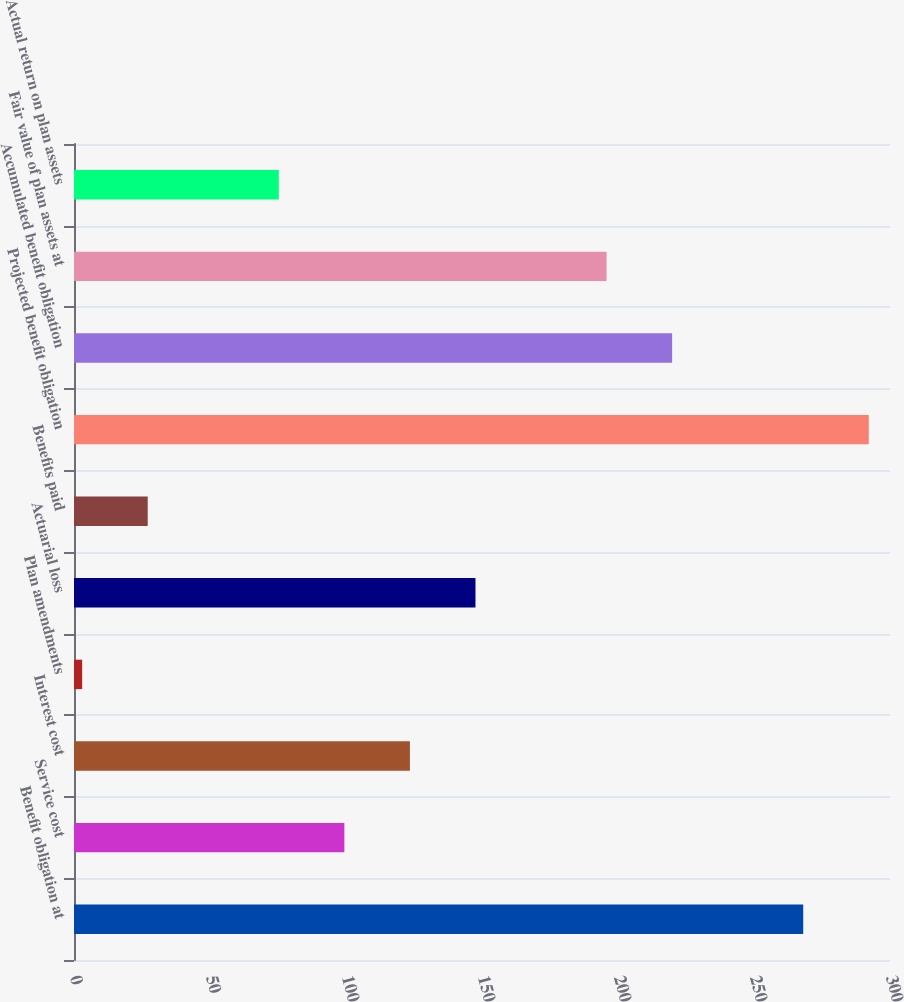Convert chart to OTSL. <chart><loc_0><loc_0><loc_500><loc_500><bar_chart><fcel>Benefit obligation at<fcel>Service cost<fcel>Interest cost<fcel>Plan amendments<fcel>Actuarial loss<fcel>Benefits paid<fcel>Projected benefit obligation<fcel>Accumulated benefit obligation<fcel>Fair value of plan assets at<fcel>Actual return on plan assets<nl><fcel>268.1<fcel>99.4<fcel>123.5<fcel>3<fcel>147.6<fcel>27.1<fcel>292.2<fcel>219.9<fcel>195.8<fcel>75.3<nl></chart> 